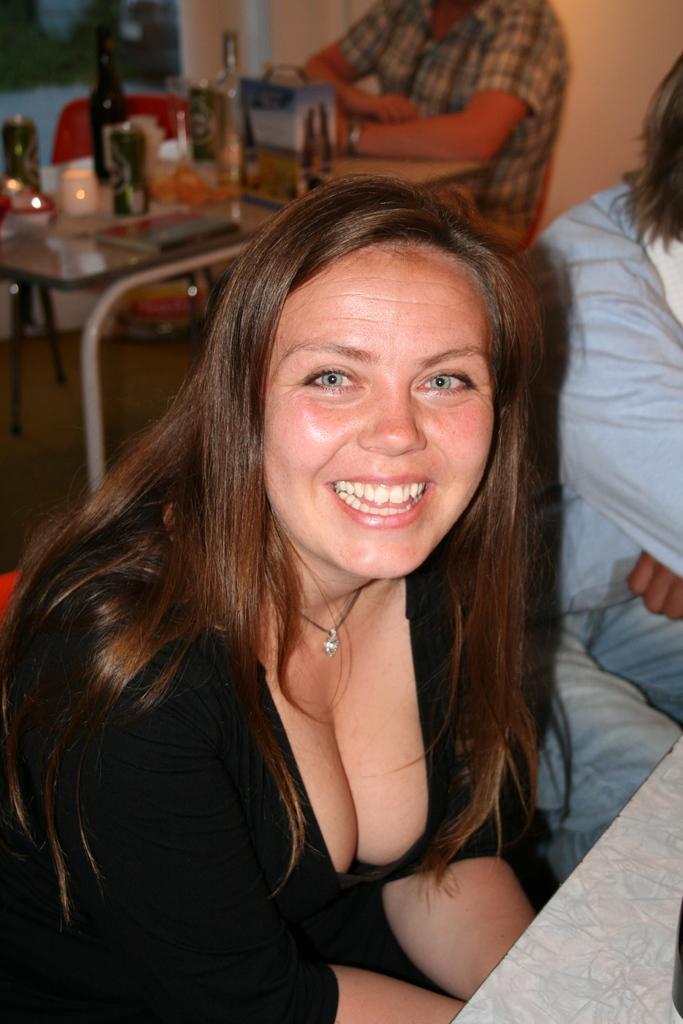How would you summarize this image in a sentence or two? In this image we can see a woman sitting on a chair and she is smiling. In the background we can see a person sitting on a chair. 